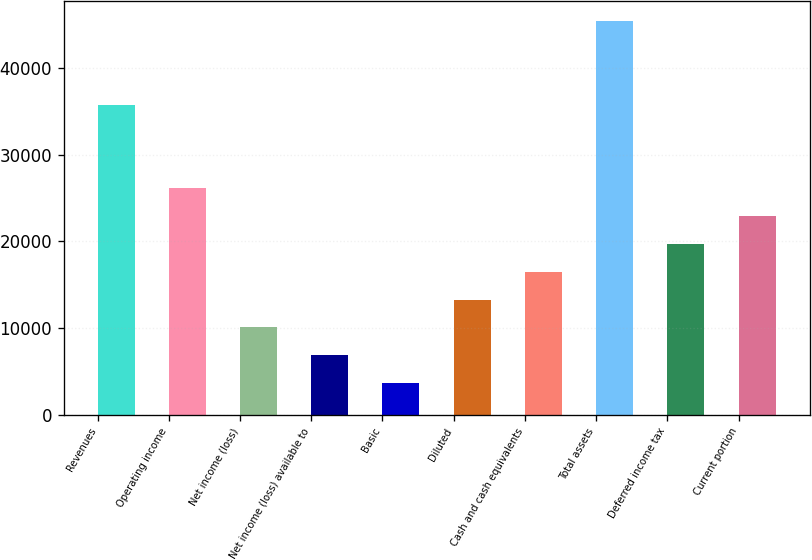Convert chart. <chart><loc_0><loc_0><loc_500><loc_500><bar_chart><fcel>Revenues<fcel>Operating income<fcel>Net income (loss)<fcel>Net income (loss) available to<fcel>Basic<fcel>Diluted<fcel>Cash and cash equivalents<fcel>Total assets<fcel>Deferred income tax<fcel>Current portion<nl><fcel>35763.5<fcel>26123<fcel>10055.5<fcel>6842<fcel>3628.5<fcel>13269<fcel>16482.5<fcel>45404<fcel>19696<fcel>22909.5<nl></chart> 